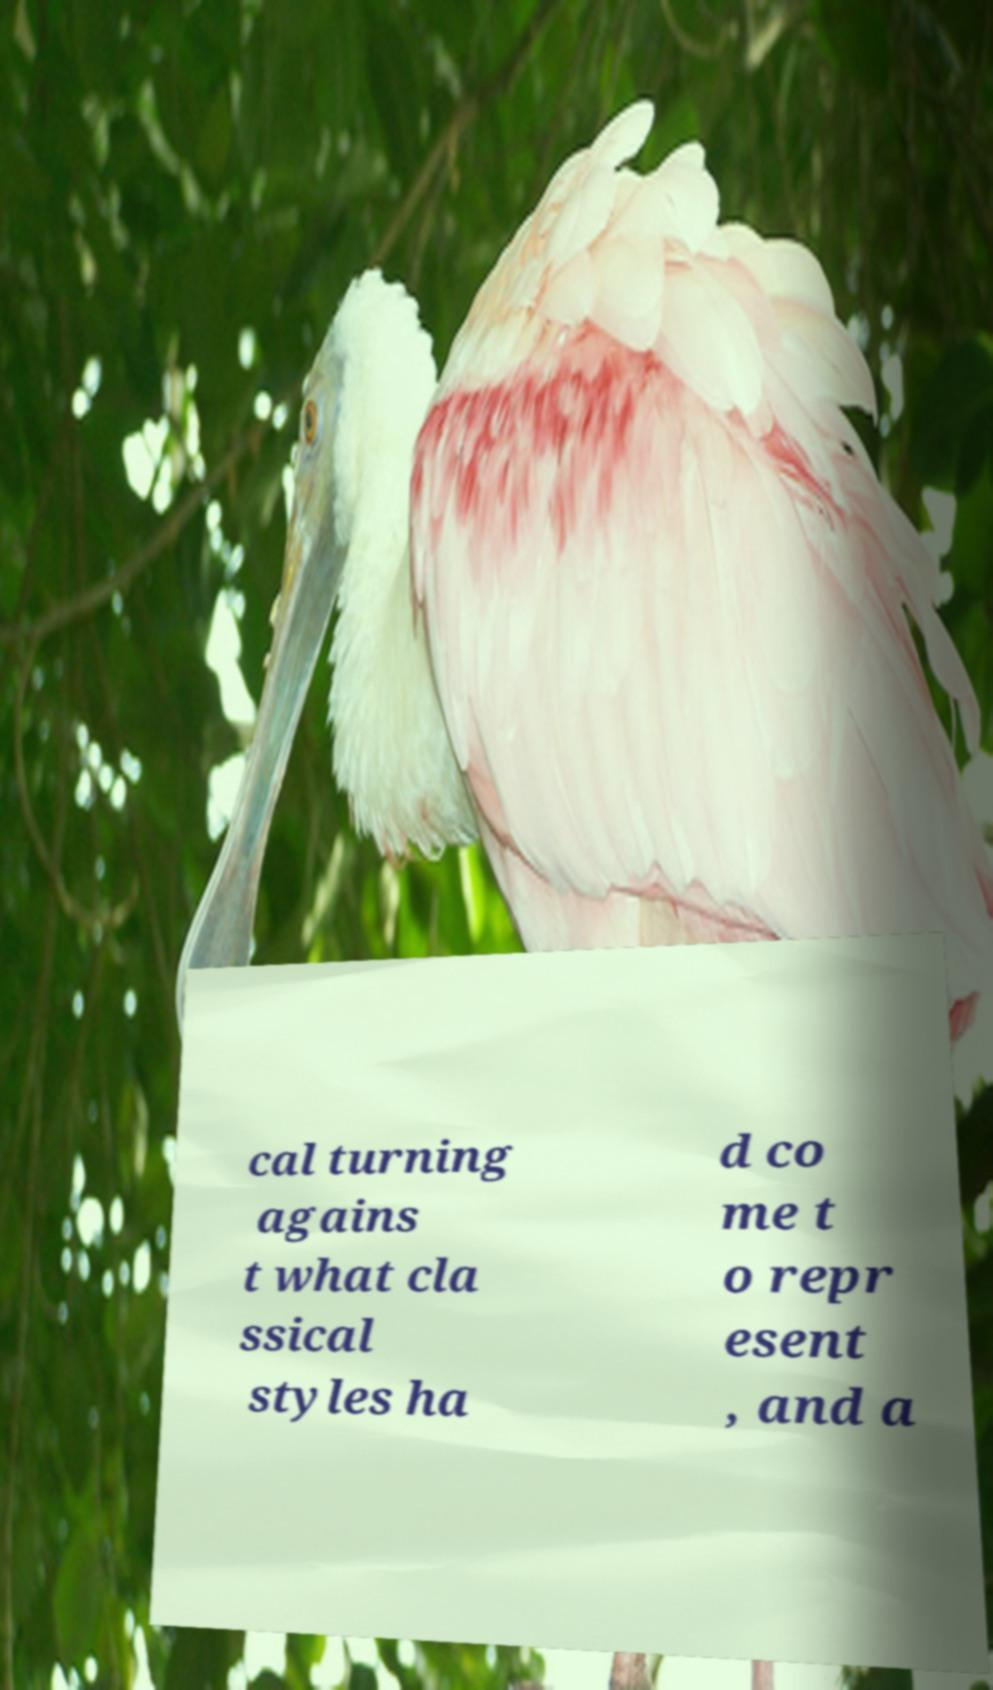For documentation purposes, I need the text within this image transcribed. Could you provide that? cal turning agains t what cla ssical styles ha d co me t o repr esent , and a 